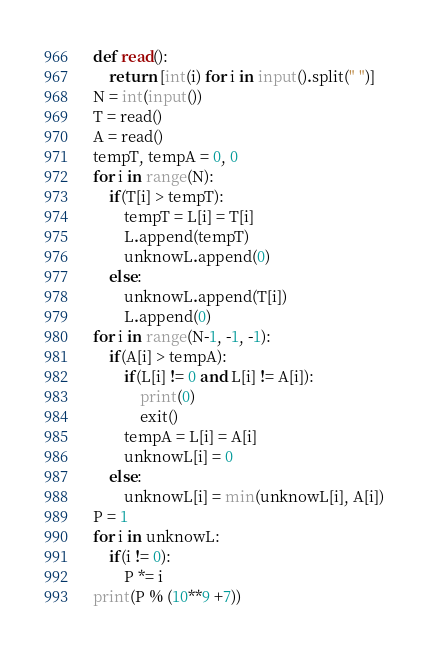Convert code to text. <code><loc_0><loc_0><loc_500><loc_500><_Python_>def read():
	return [int(i) for i in input().split(" ")]
N = int(input())
T = read()
A = read()
tempT, tempA = 0, 0
for i in range(N):
	if(T[i] > tempT):
		tempT = L[i] = T[i]
		L.append(tempT)
		unknowL.append(0)
	else:
		unknowL.append(T[i])
		L.append(0)
for i in range(N-1, -1, -1):
	if(A[i] > tempA):
		if(L[i] != 0 and L[i] != A[i]):
			print(0)
			exit()
		tempA = L[i] = A[i]
		unknowL[i] = 0
	else:
		unknowL[i] = min(unknowL[i], A[i])
P = 1 
for i in unknowL:
	if(i != 0):
		P *= i	
print(P % (10**9 +7))</code> 